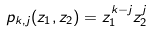Convert formula to latex. <formula><loc_0><loc_0><loc_500><loc_500>p _ { k , j } ( z _ { 1 } , z _ { 2 } ) = z _ { 1 } ^ { k - j } z _ { 2 } ^ { j }</formula> 